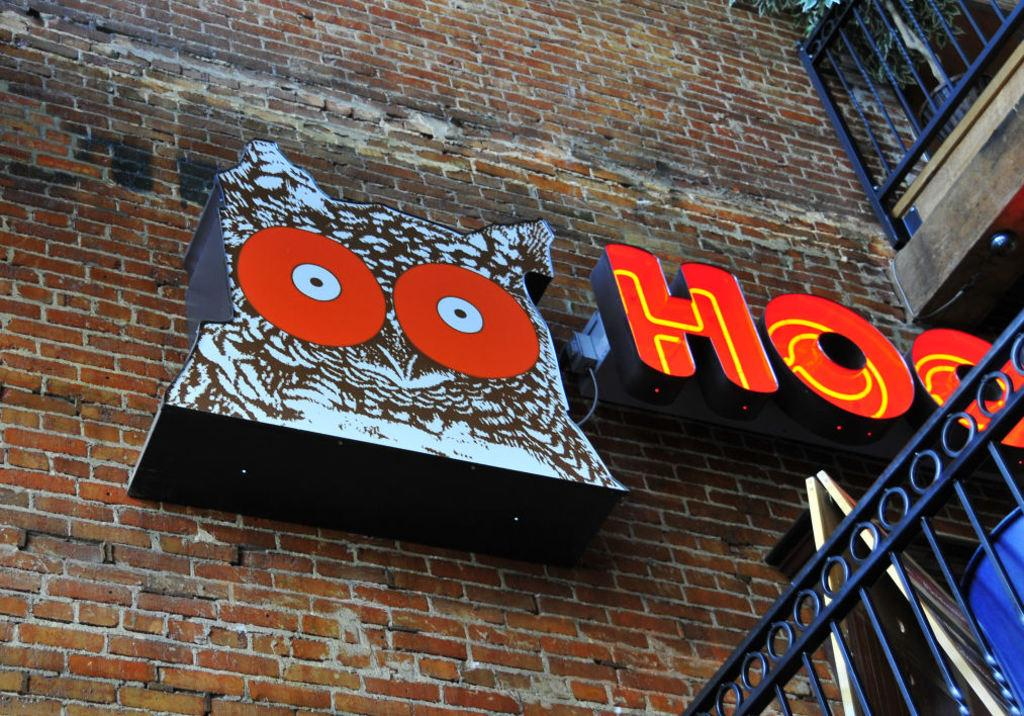<image>
Present a compact description of the photo's key features. The sign on the exterior of this brick building indicates it is a Hooters restaurant. 